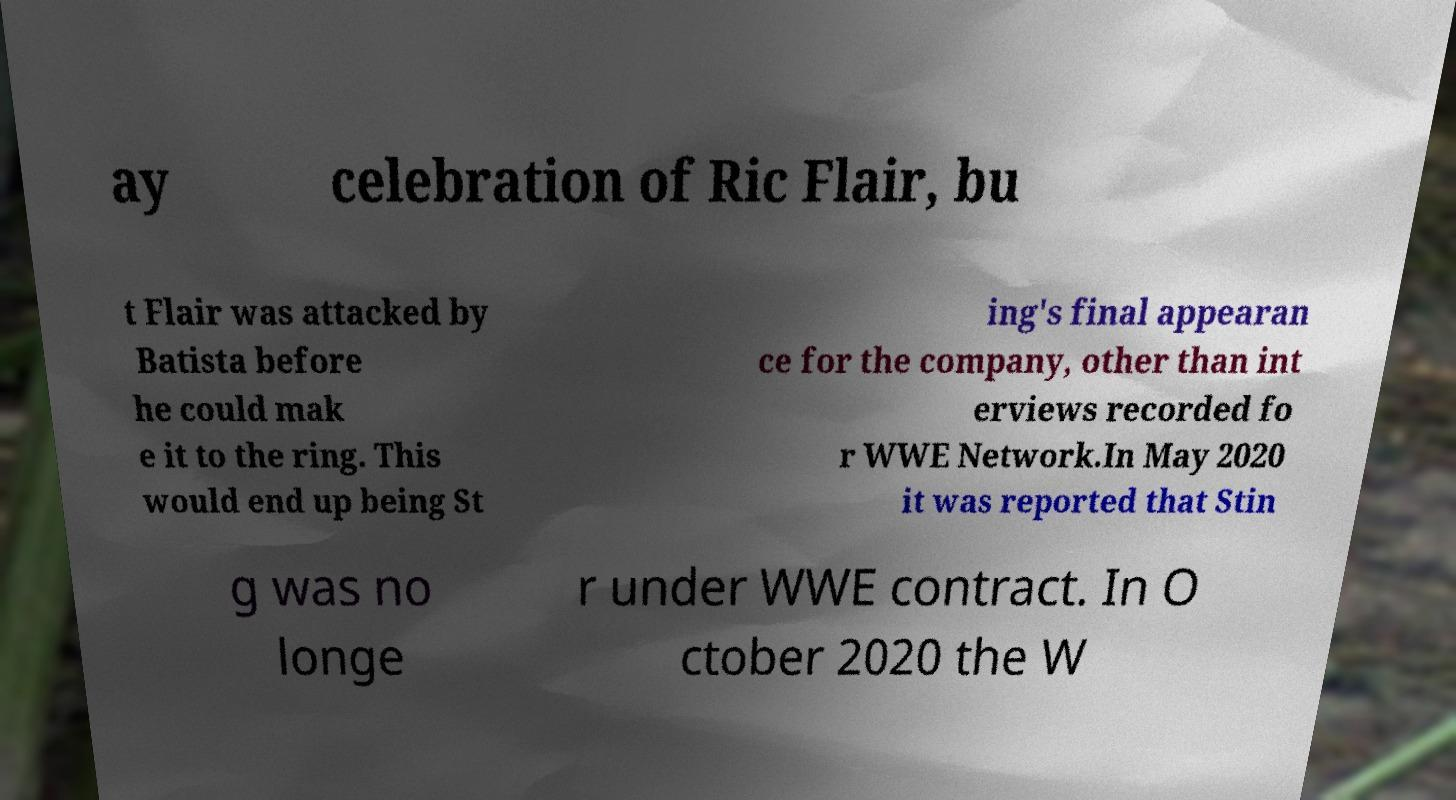I need the written content from this picture converted into text. Can you do that? ay celebration of Ric Flair, bu t Flair was attacked by Batista before he could mak e it to the ring. This would end up being St ing's final appearan ce for the company, other than int erviews recorded fo r WWE Network.In May 2020 it was reported that Stin g was no longe r under WWE contract. In O ctober 2020 the W 